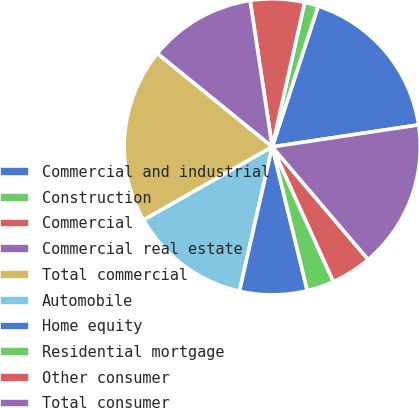<chart> <loc_0><loc_0><loc_500><loc_500><pie_chart><fcel>Commercial and industrial<fcel>Construction<fcel>Commercial<fcel>Commercial real estate<fcel>Total commercial<fcel>Automobile<fcel>Home equity<fcel>Residential mortgage<fcel>Other consumer<fcel>Total consumer<nl><fcel>17.61%<fcel>1.51%<fcel>5.9%<fcel>11.76%<fcel>19.08%<fcel>13.22%<fcel>7.36%<fcel>2.97%<fcel>4.44%<fcel>16.15%<nl></chart> 